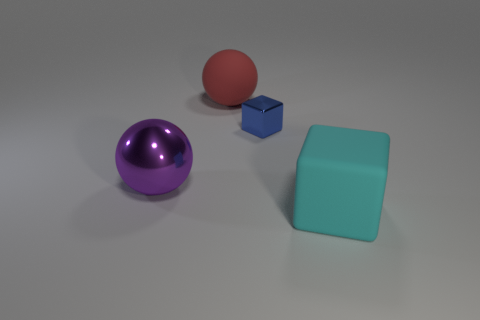Add 4 tiny cyan metal things. How many objects exist? 8 Add 2 blue things. How many blue things are left? 3 Add 3 cyan rubber things. How many cyan rubber things exist? 4 Subtract 0 blue spheres. How many objects are left? 4 Subtract all metallic objects. Subtract all tiny brown cylinders. How many objects are left? 2 